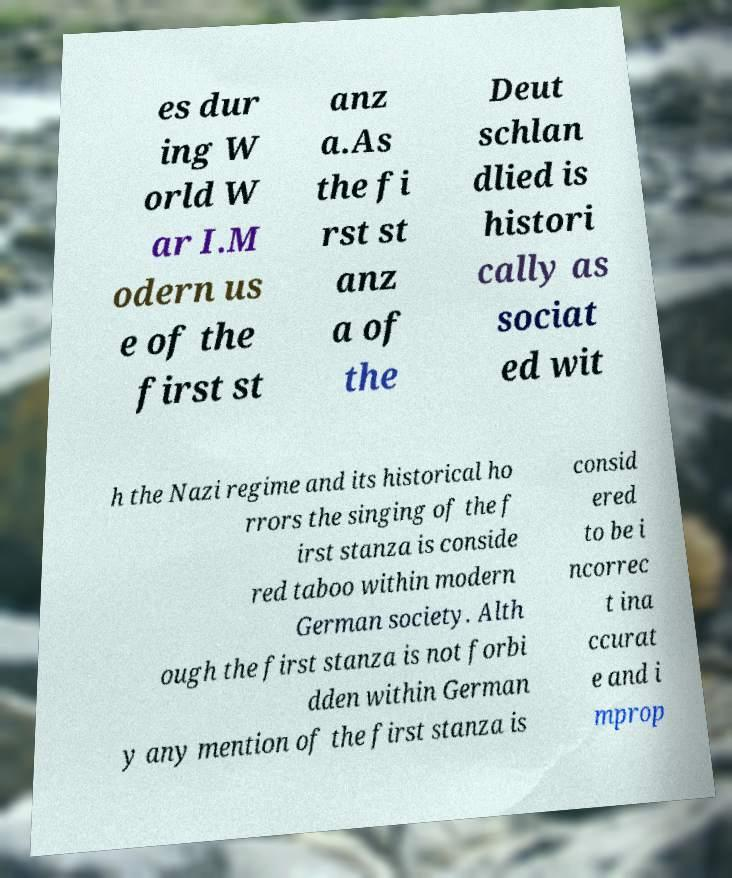Could you assist in decoding the text presented in this image and type it out clearly? es dur ing W orld W ar I.M odern us e of the first st anz a.As the fi rst st anz a of the Deut schlan dlied is histori cally as sociat ed wit h the Nazi regime and its historical ho rrors the singing of the f irst stanza is conside red taboo within modern German society. Alth ough the first stanza is not forbi dden within German y any mention of the first stanza is consid ered to be i ncorrec t ina ccurat e and i mprop 